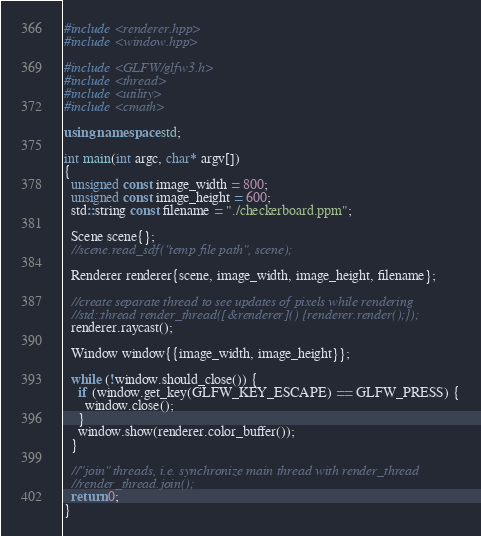Convert code to text. <code><loc_0><loc_0><loc_500><loc_500><_C++_>#include <renderer.hpp>
#include <window.hpp>

#include <GLFW/glfw3.h>
#include <thread>
#include <utility>
#include <cmath>

using namespace std;

int main(int argc, char* argv[])
{
  unsigned const image_width = 800;
  unsigned const image_height = 600;
  std::string const filename = "./checkerboard.ppm";

  Scene scene{};
  //scene.read_sdf("temp file path", scene);

  Renderer renderer{scene, image_width, image_height, filename};

  //create separate thread to see updates of pixels while rendering
  //std::thread render_thread([&renderer]() {renderer.render();});
  renderer.raycast();

  Window window{{image_width, image_height}};

  while (!window.should_close()) {
    if (window.get_key(GLFW_KEY_ESCAPE) == GLFW_PRESS) {
      window.close();
    }
    window.show(renderer.color_buffer());
  }

  //"join" threads, i.e. synchronize main thread with render_thread
  //render_thread.join();
  return 0;
}
</code> 